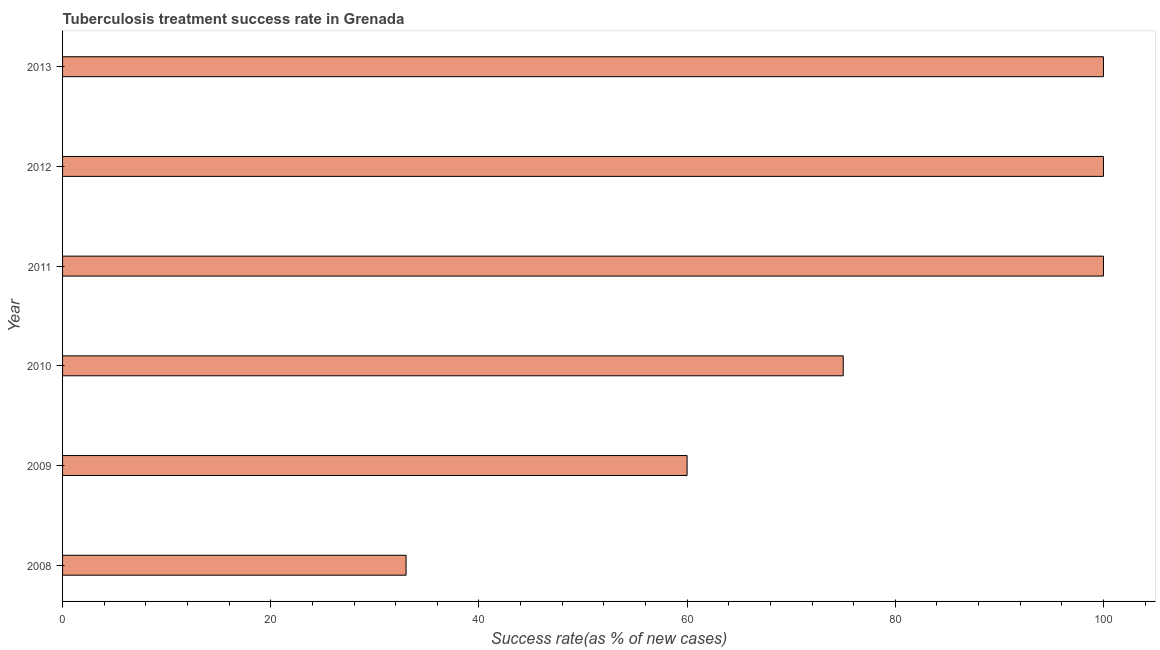What is the title of the graph?
Give a very brief answer. Tuberculosis treatment success rate in Grenada. What is the label or title of the X-axis?
Make the answer very short. Success rate(as % of new cases). What is the label or title of the Y-axis?
Your answer should be very brief. Year. In which year was the tuberculosis treatment success rate maximum?
Your response must be concise. 2011. What is the sum of the tuberculosis treatment success rate?
Your answer should be compact. 468. What is the median tuberculosis treatment success rate?
Provide a short and direct response. 87.5. What is the ratio of the tuberculosis treatment success rate in 2010 to that in 2012?
Provide a succinct answer. 0.75. Is the tuberculosis treatment success rate in 2009 less than that in 2012?
Provide a succinct answer. Yes. Is the difference between the tuberculosis treatment success rate in 2009 and 2011 greater than the difference between any two years?
Provide a succinct answer. No. What is the difference between the highest and the lowest tuberculosis treatment success rate?
Your answer should be compact. 67. Are all the bars in the graph horizontal?
Give a very brief answer. Yes. How many years are there in the graph?
Your response must be concise. 6. Are the values on the major ticks of X-axis written in scientific E-notation?
Keep it short and to the point. No. What is the Success rate(as % of new cases) in 2008?
Your answer should be compact. 33. What is the Success rate(as % of new cases) of 2010?
Give a very brief answer. 75. What is the Success rate(as % of new cases) in 2011?
Ensure brevity in your answer.  100. What is the Success rate(as % of new cases) in 2012?
Your response must be concise. 100. What is the Success rate(as % of new cases) of 2013?
Give a very brief answer. 100. What is the difference between the Success rate(as % of new cases) in 2008 and 2010?
Offer a terse response. -42. What is the difference between the Success rate(as % of new cases) in 2008 and 2011?
Make the answer very short. -67. What is the difference between the Success rate(as % of new cases) in 2008 and 2012?
Keep it short and to the point. -67. What is the difference between the Success rate(as % of new cases) in 2008 and 2013?
Provide a short and direct response. -67. What is the difference between the Success rate(as % of new cases) in 2009 and 2011?
Offer a terse response. -40. What is the difference between the Success rate(as % of new cases) in 2009 and 2012?
Ensure brevity in your answer.  -40. What is the difference between the Success rate(as % of new cases) in 2010 and 2012?
Keep it short and to the point. -25. What is the difference between the Success rate(as % of new cases) in 2010 and 2013?
Offer a very short reply. -25. What is the ratio of the Success rate(as % of new cases) in 2008 to that in 2009?
Provide a succinct answer. 0.55. What is the ratio of the Success rate(as % of new cases) in 2008 to that in 2010?
Your answer should be very brief. 0.44. What is the ratio of the Success rate(as % of new cases) in 2008 to that in 2011?
Give a very brief answer. 0.33. What is the ratio of the Success rate(as % of new cases) in 2008 to that in 2012?
Make the answer very short. 0.33. What is the ratio of the Success rate(as % of new cases) in 2008 to that in 2013?
Give a very brief answer. 0.33. What is the ratio of the Success rate(as % of new cases) in 2009 to that in 2012?
Provide a short and direct response. 0.6. What is the ratio of the Success rate(as % of new cases) in 2010 to that in 2011?
Your answer should be compact. 0.75. What is the ratio of the Success rate(as % of new cases) in 2010 to that in 2013?
Provide a short and direct response. 0.75. What is the ratio of the Success rate(as % of new cases) in 2012 to that in 2013?
Your answer should be very brief. 1. 